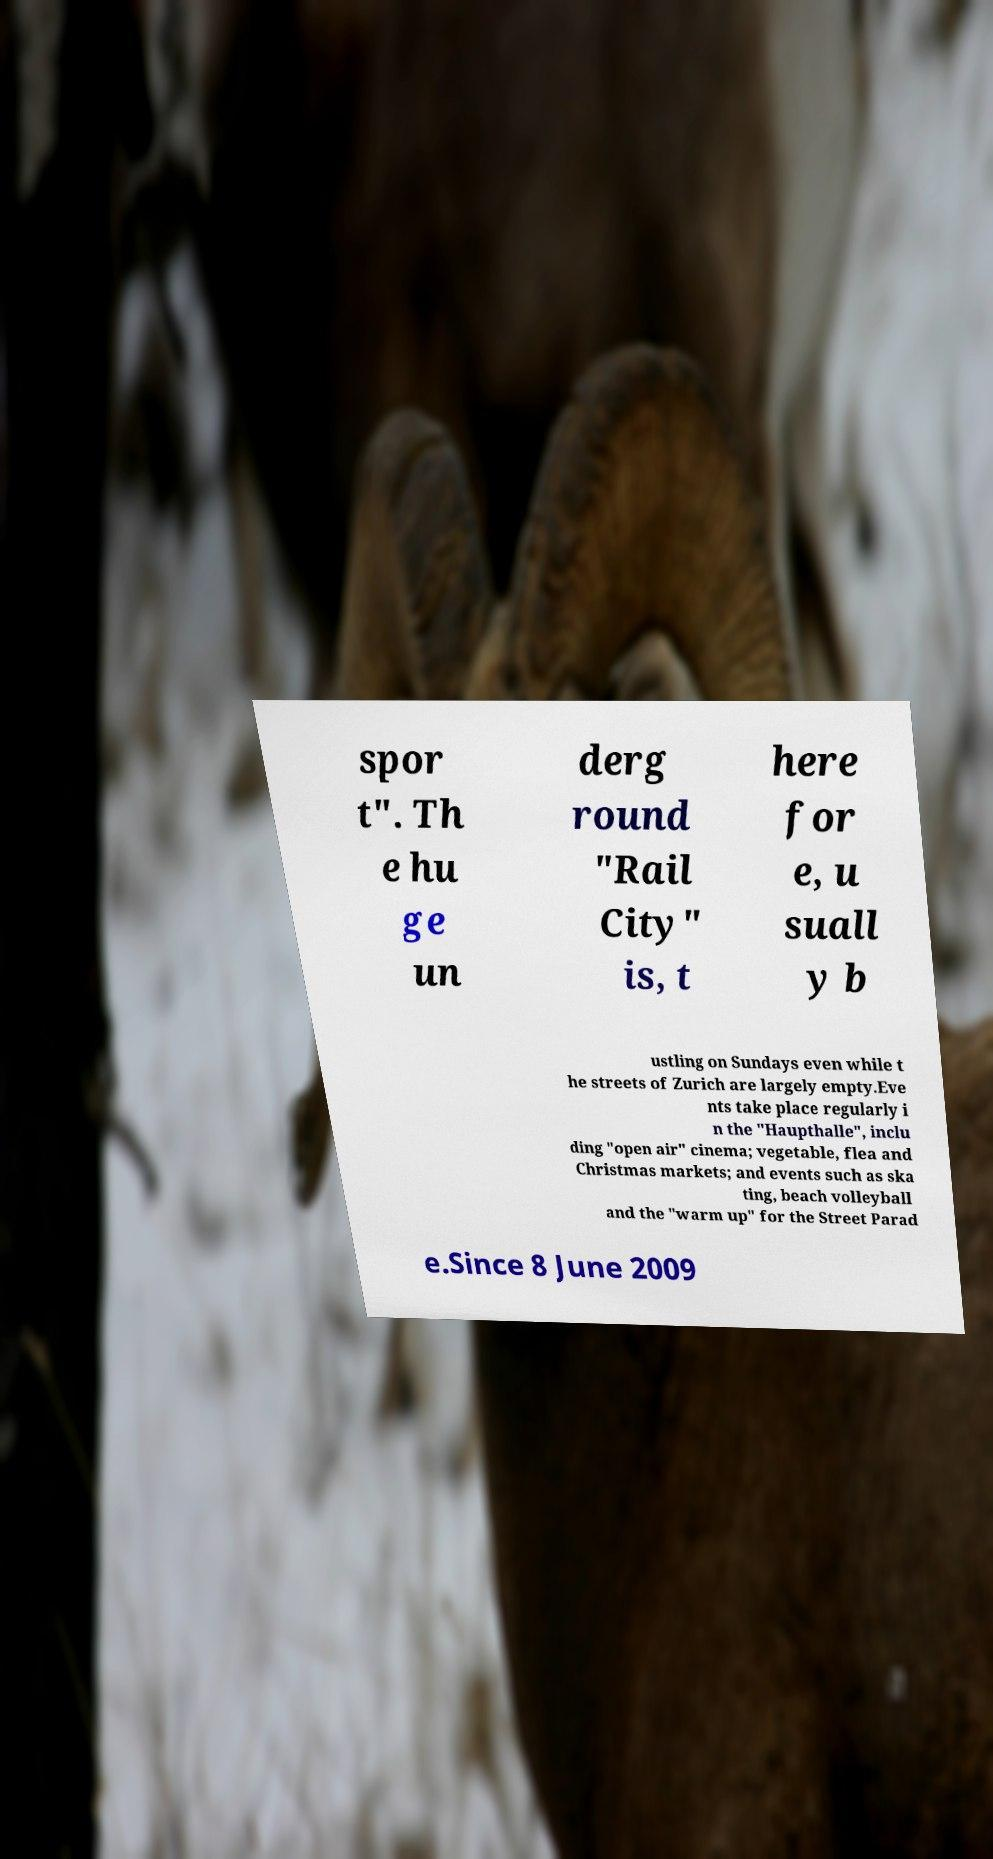For documentation purposes, I need the text within this image transcribed. Could you provide that? spor t". Th e hu ge un derg round "Rail City" is, t here for e, u suall y b ustling on Sundays even while t he streets of Zurich are largely empty.Eve nts take place regularly i n the "Haupthalle", inclu ding "open air" cinema; vegetable, flea and Christmas markets; and events such as ska ting, beach volleyball and the "warm up" for the Street Parad e.Since 8 June 2009 